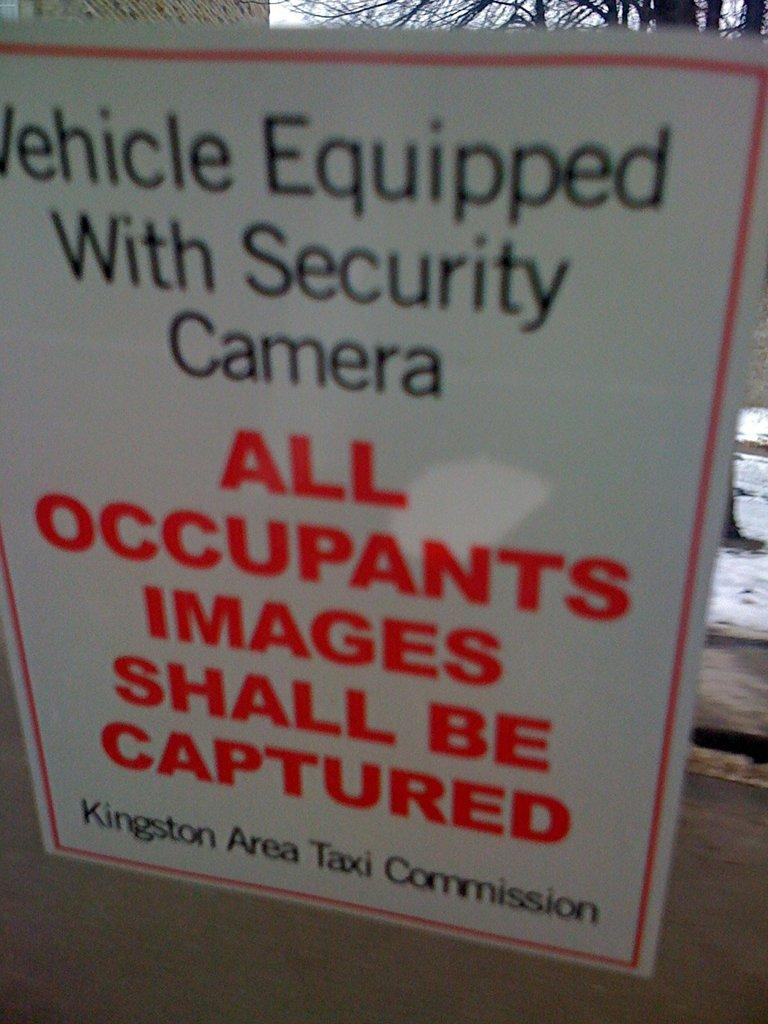<image>
Offer a succinct explanation of the picture presented. A notice hangs in a taxi letting people know that all occupants images shall be captured. 